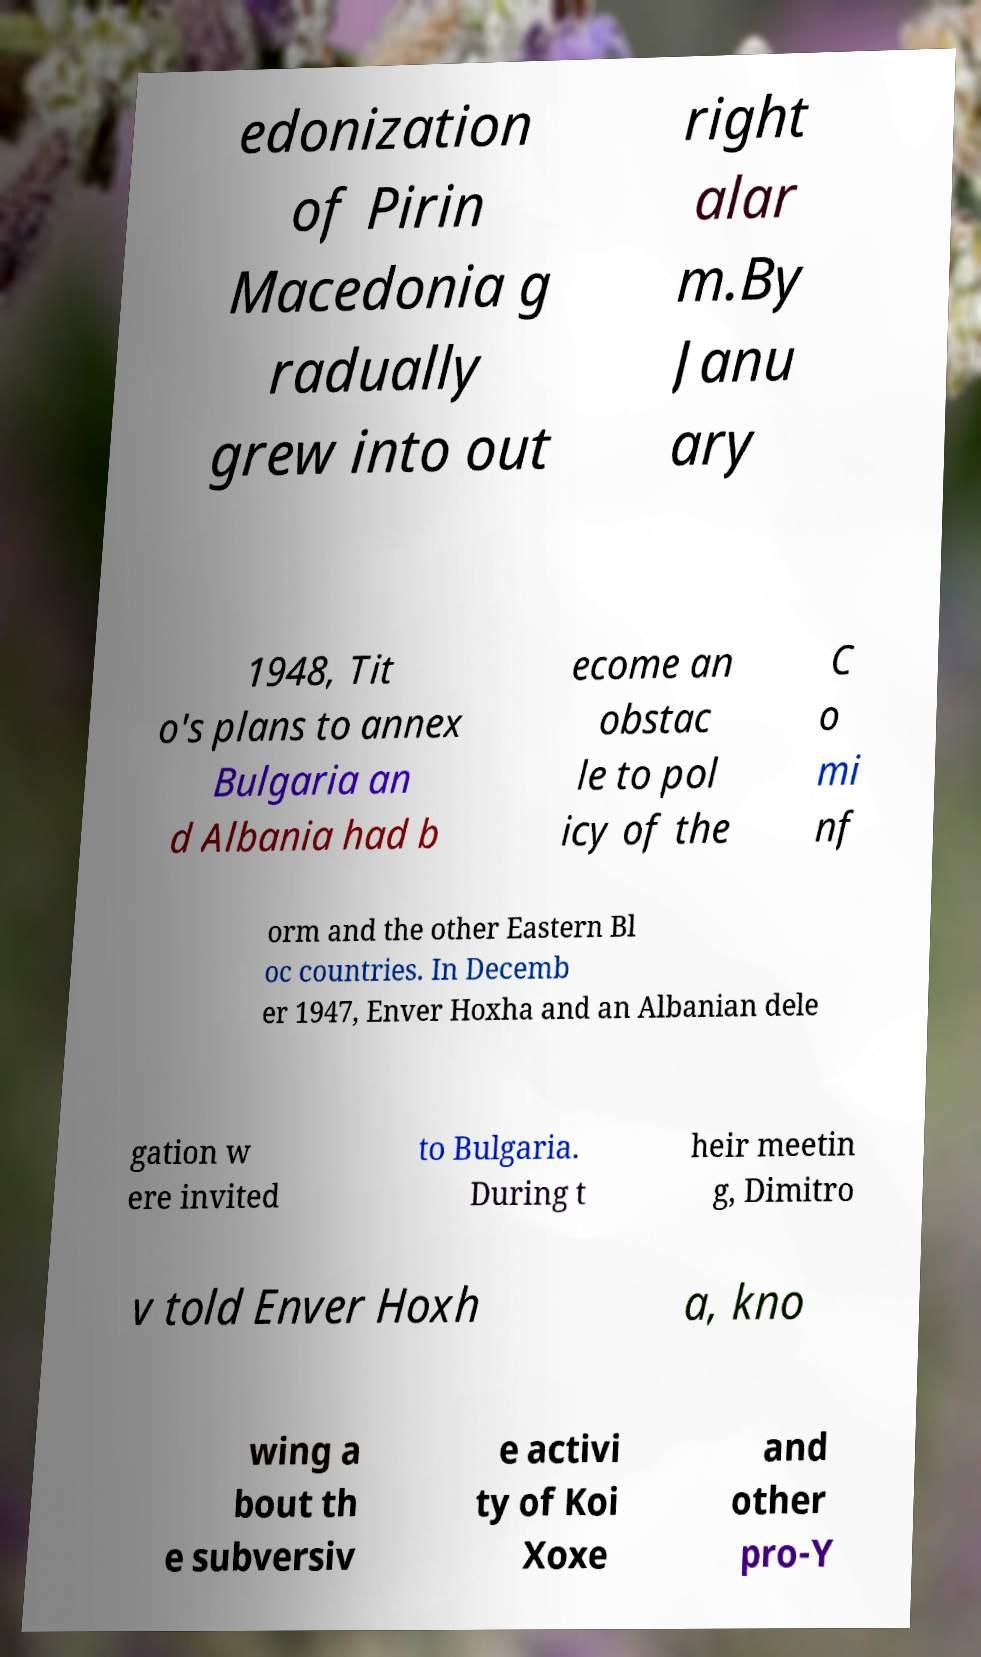What messages or text are displayed in this image? I need them in a readable, typed format. edonization of Pirin Macedonia g radually grew into out right alar m.By Janu ary 1948, Tit o's plans to annex Bulgaria an d Albania had b ecome an obstac le to pol icy of the C o mi nf orm and the other Eastern Bl oc countries. In Decemb er 1947, Enver Hoxha and an Albanian dele gation w ere invited to Bulgaria. During t heir meetin g, Dimitro v told Enver Hoxh a, kno wing a bout th e subversiv e activi ty of Koi Xoxe and other pro-Y 